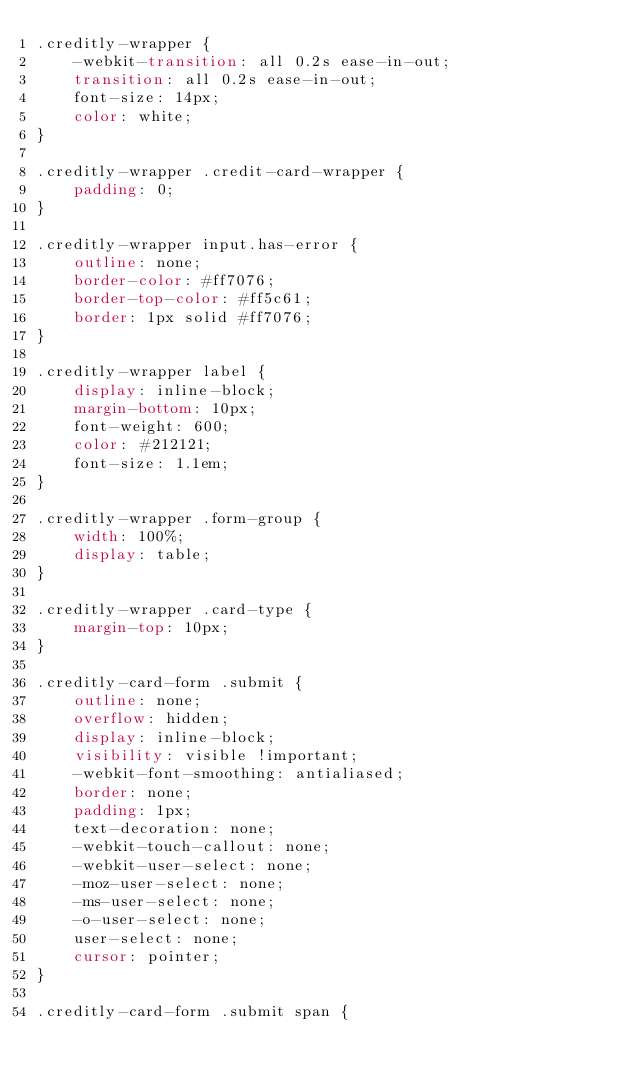<code> <loc_0><loc_0><loc_500><loc_500><_CSS_>.creditly-wrapper {
    -webkit-transition: all 0.2s ease-in-out;
    transition: all 0.2s ease-in-out;
    font-size: 14px;
    color: white;
}

.creditly-wrapper .credit-card-wrapper {
    padding: 0;
}

.creditly-wrapper input.has-error {
    outline: none;
    border-color: #ff7076;
    border-top-color: #ff5c61;
    border: 1px solid #ff7076;
}

.creditly-wrapper label {
    display: inline-block;
    margin-bottom: 10px;
    font-weight: 600;
    color: #212121;
    font-size: 1.1em;
}

.creditly-wrapper .form-group {
    width: 100%;
    display: table;
}

.creditly-wrapper .card-type {
    margin-top: 10px;
}

.creditly-card-form .submit {
    outline: none;
    overflow: hidden;
    display: inline-block;
    visibility: visible !important;
    -webkit-font-smoothing: antialiased;
    border: none;
    padding: 1px;
    text-decoration: none;
    -webkit-touch-callout: none;
    -webkit-user-select: none;
    -moz-user-select: none;
    -ms-user-select: none;
    -o-user-select: none;
    user-select: none;
    cursor: pointer;
}

.creditly-card-form .submit span {</code> 